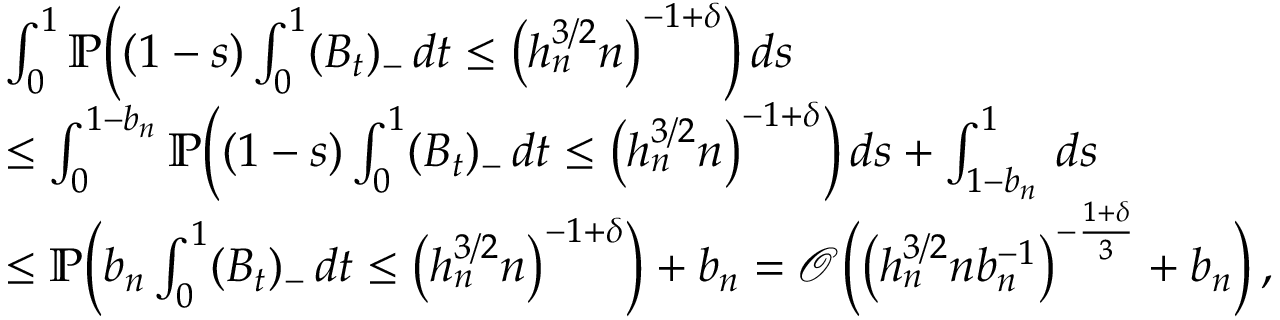Convert formula to latex. <formula><loc_0><loc_0><loc_500><loc_500>\begin{array} { r l } & { \int _ { 0 } ^ { 1 } \mathbb { P } \left ( ( 1 - s ) \int _ { 0 } ^ { 1 } ( B _ { t } ) _ { - } \, d t \leq \left ( h _ { n } ^ { 3 / 2 } n \right ) ^ { - 1 + \delta } \right ) \, d s } \\ & { \leq \int _ { 0 } ^ { 1 - b _ { n } } \mathbb { P } \left ( ( 1 - s ) \int _ { 0 } ^ { 1 } ( B _ { t } ) _ { - } \, d t \leq \left ( h _ { n } ^ { 3 / 2 } n \right ) ^ { - 1 + \delta } \right ) \, d s + \int _ { 1 - b _ { n } } ^ { 1 } \, d s } \\ & { \leq \mathbb { P } \left ( b _ { n } \int _ { 0 } ^ { 1 } ( B _ { t } ) _ { - } \, d t \leq \left ( h _ { n } ^ { 3 / 2 } n \right ) ^ { - 1 + \delta } \right ) + b _ { n } = \mathcal { O } \left ( \left ( h _ { n } ^ { 3 / 2 } n b _ { n } ^ { - 1 } \right ) ^ { - \frac { 1 + \delta } { 3 } } + b _ { n } \right ) \, , } \end{array}</formula> 